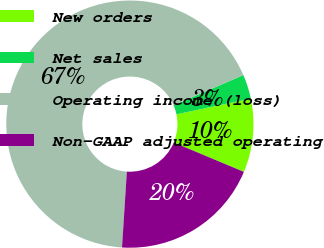<chart> <loc_0><loc_0><loc_500><loc_500><pie_chart><fcel>New orders<fcel>Net sales<fcel>Operating income (loss)<fcel>Non-GAAP adjusted operating<nl><fcel>9.62%<fcel>3.19%<fcel>67.48%<fcel>19.7%<nl></chart> 